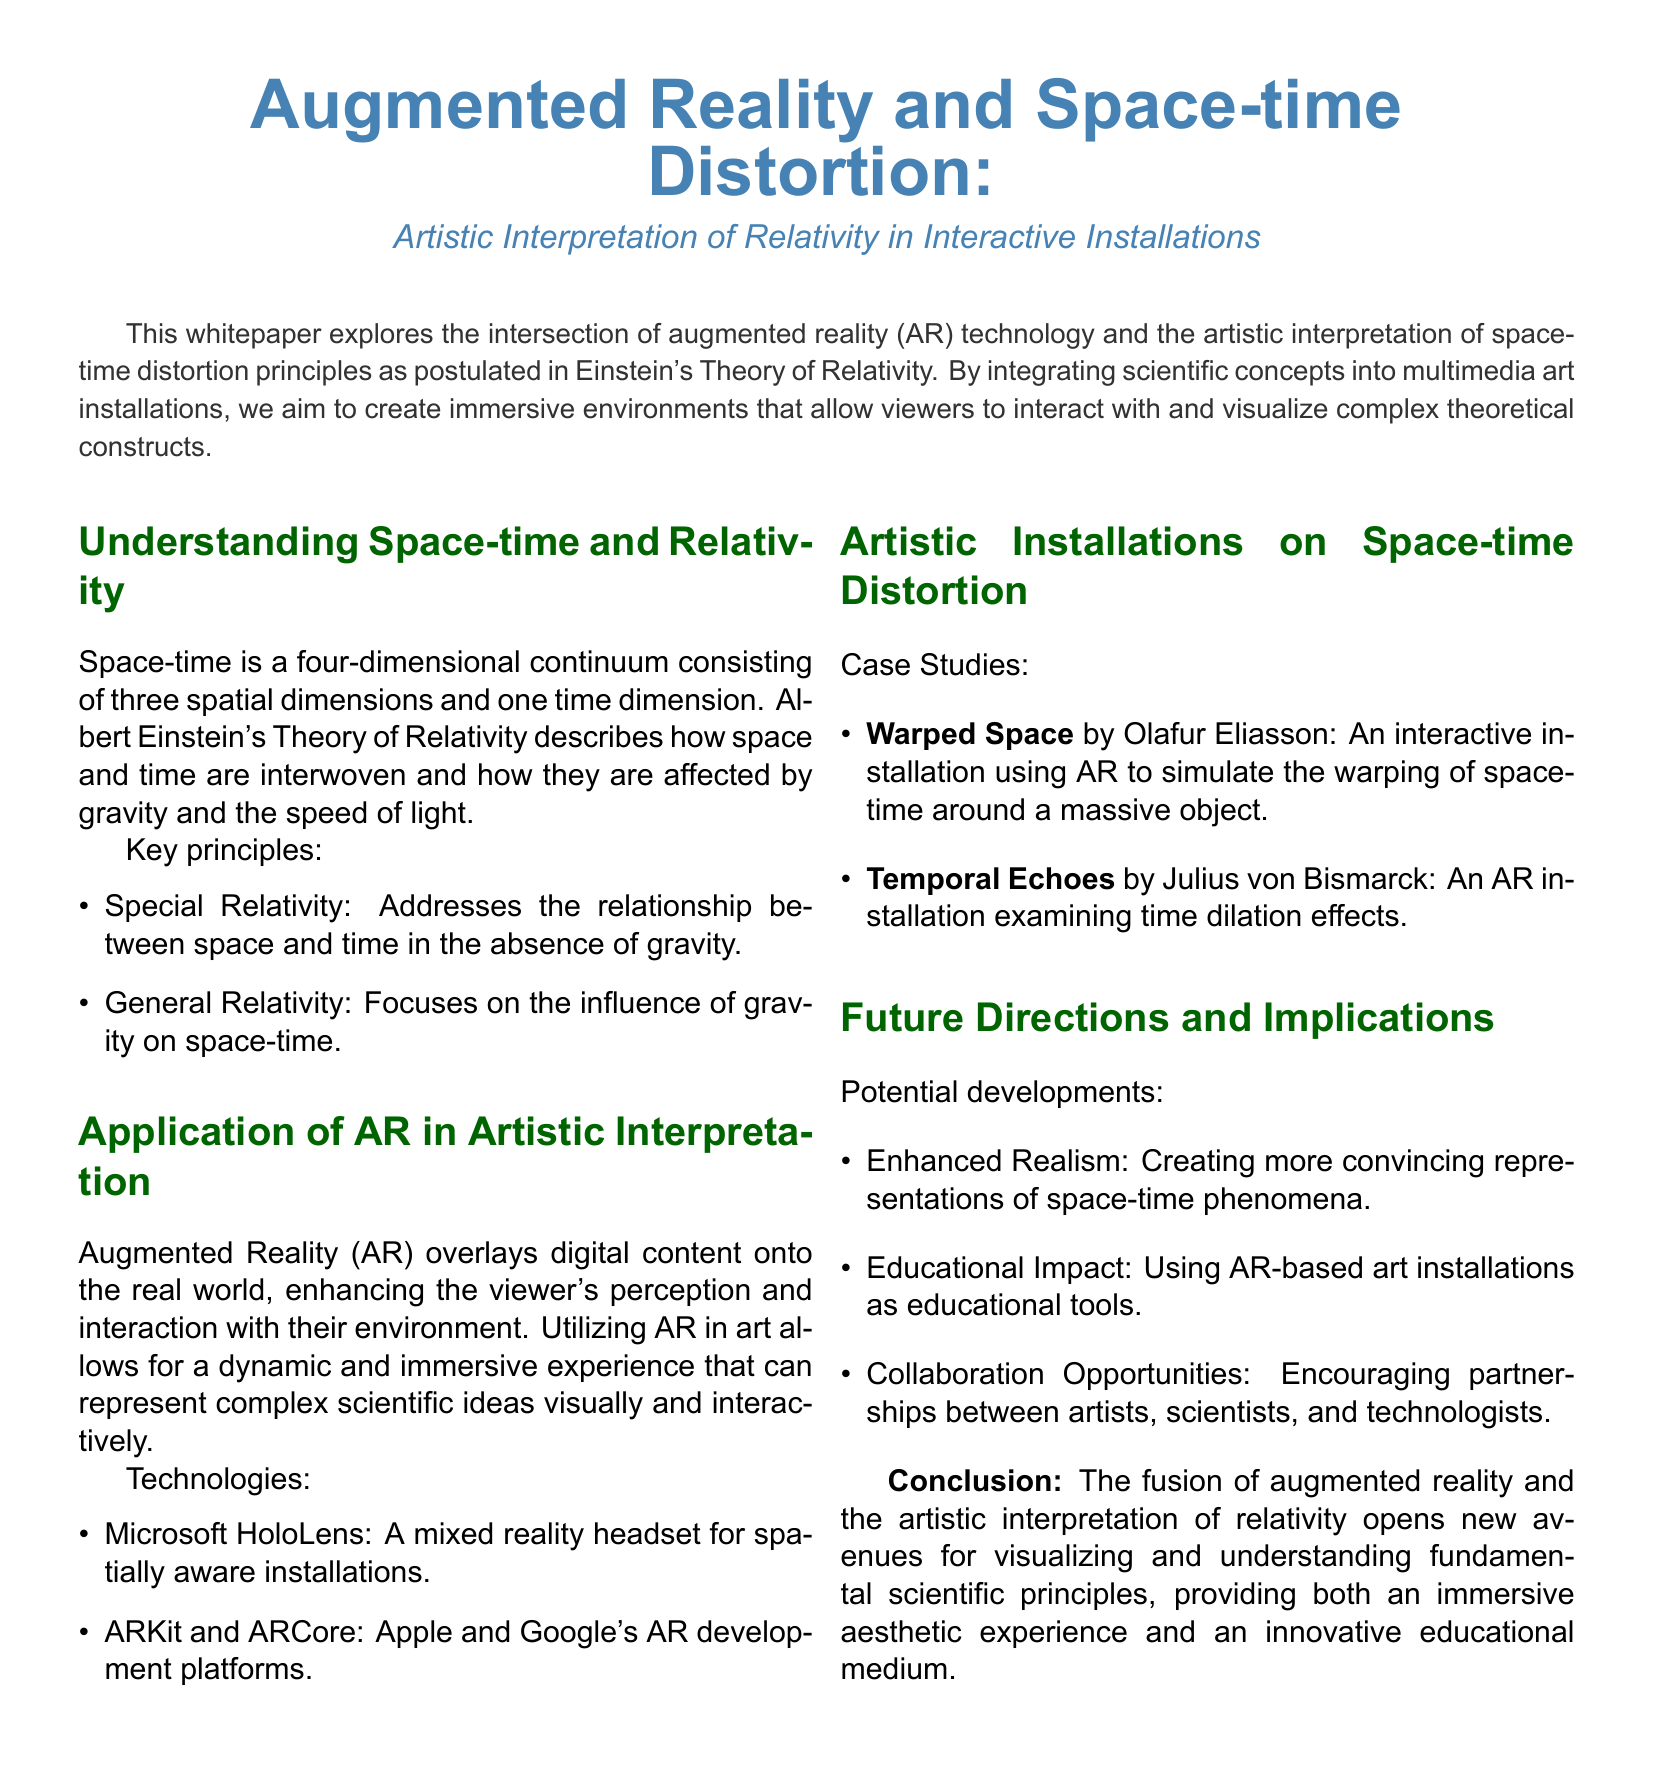What are the two key principles of relativity? The document lists Special Relativity and General Relativity as the two key principles.
Answer: Special Relativity, General Relativity Which AR platforms are mentioned? The document states that ARKit and ARCore are the AR development platforms mentioned.
Answer: ARKit and ARCore Who created the installation "Warped Space"? The document names Olafur Eliasson as the creator of "Warped Space."
Answer: Olafur Eliasson What does the installation "Temporal Echoes" examine? The document explains that "Temporal Echoes" examines time dilation effects.
Answer: Time dilation effects What is one potential development mentioned for future directions? The document states that enhanced realism is one potential development outlined for future directions.
Answer: Enhanced Realism How does augmented reality affect viewer interactions? The document describes that AR enhances the viewer's perception and interaction with their environment.
Answer: Enhances perception and interaction 